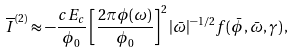<formula> <loc_0><loc_0><loc_500><loc_500>\overline { I } ^ { ( 2 ) } \approx - \frac { c E _ { c } } { \phi _ { 0 } } \left [ \frac { 2 \pi \phi ( \omega ) } { \phi _ { 0 } } \right ] ^ { 2 } | \bar { \omega } | ^ { - 1 / 2 } f ( \bar { \phi } , \bar { \omega } , \gamma ) \, ,</formula> 